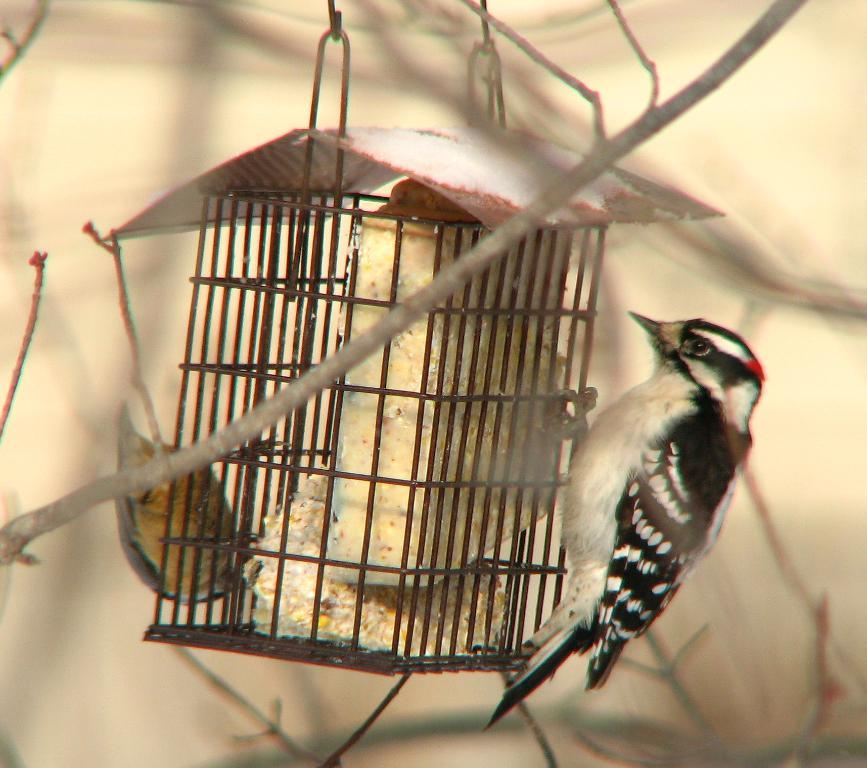What is located in the center of the image? There is a cage in the center of the image. What is inside the cage? There are birds in the cage. What can be seen in the background of the image? There are twigs visible in the background of the image. How much profit did the ducks make in the image? There are no ducks present in the image, so it is not possible to determine any profit made by them. 